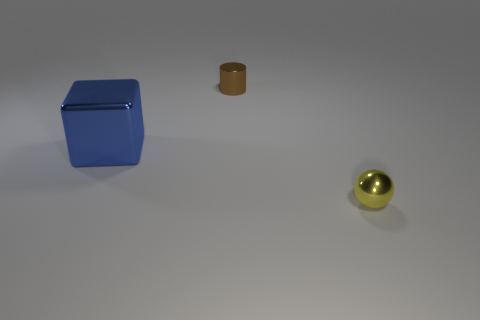Subtract all green cubes. Subtract all blue cylinders. How many cubes are left? 1 Add 2 tiny brown things. How many objects exist? 5 Subtract all blocks. How many objects are left? 2 Subtract all big shiny balls. Subtract all blue objects. How many objects are left? 2 Add 1 small yellow things. How many small yellow things are left? 2 Add 2 big purple cubes. How many big purple cubes exist? 2 Subtract 0 cyan blocks. How many objects are left? 3 